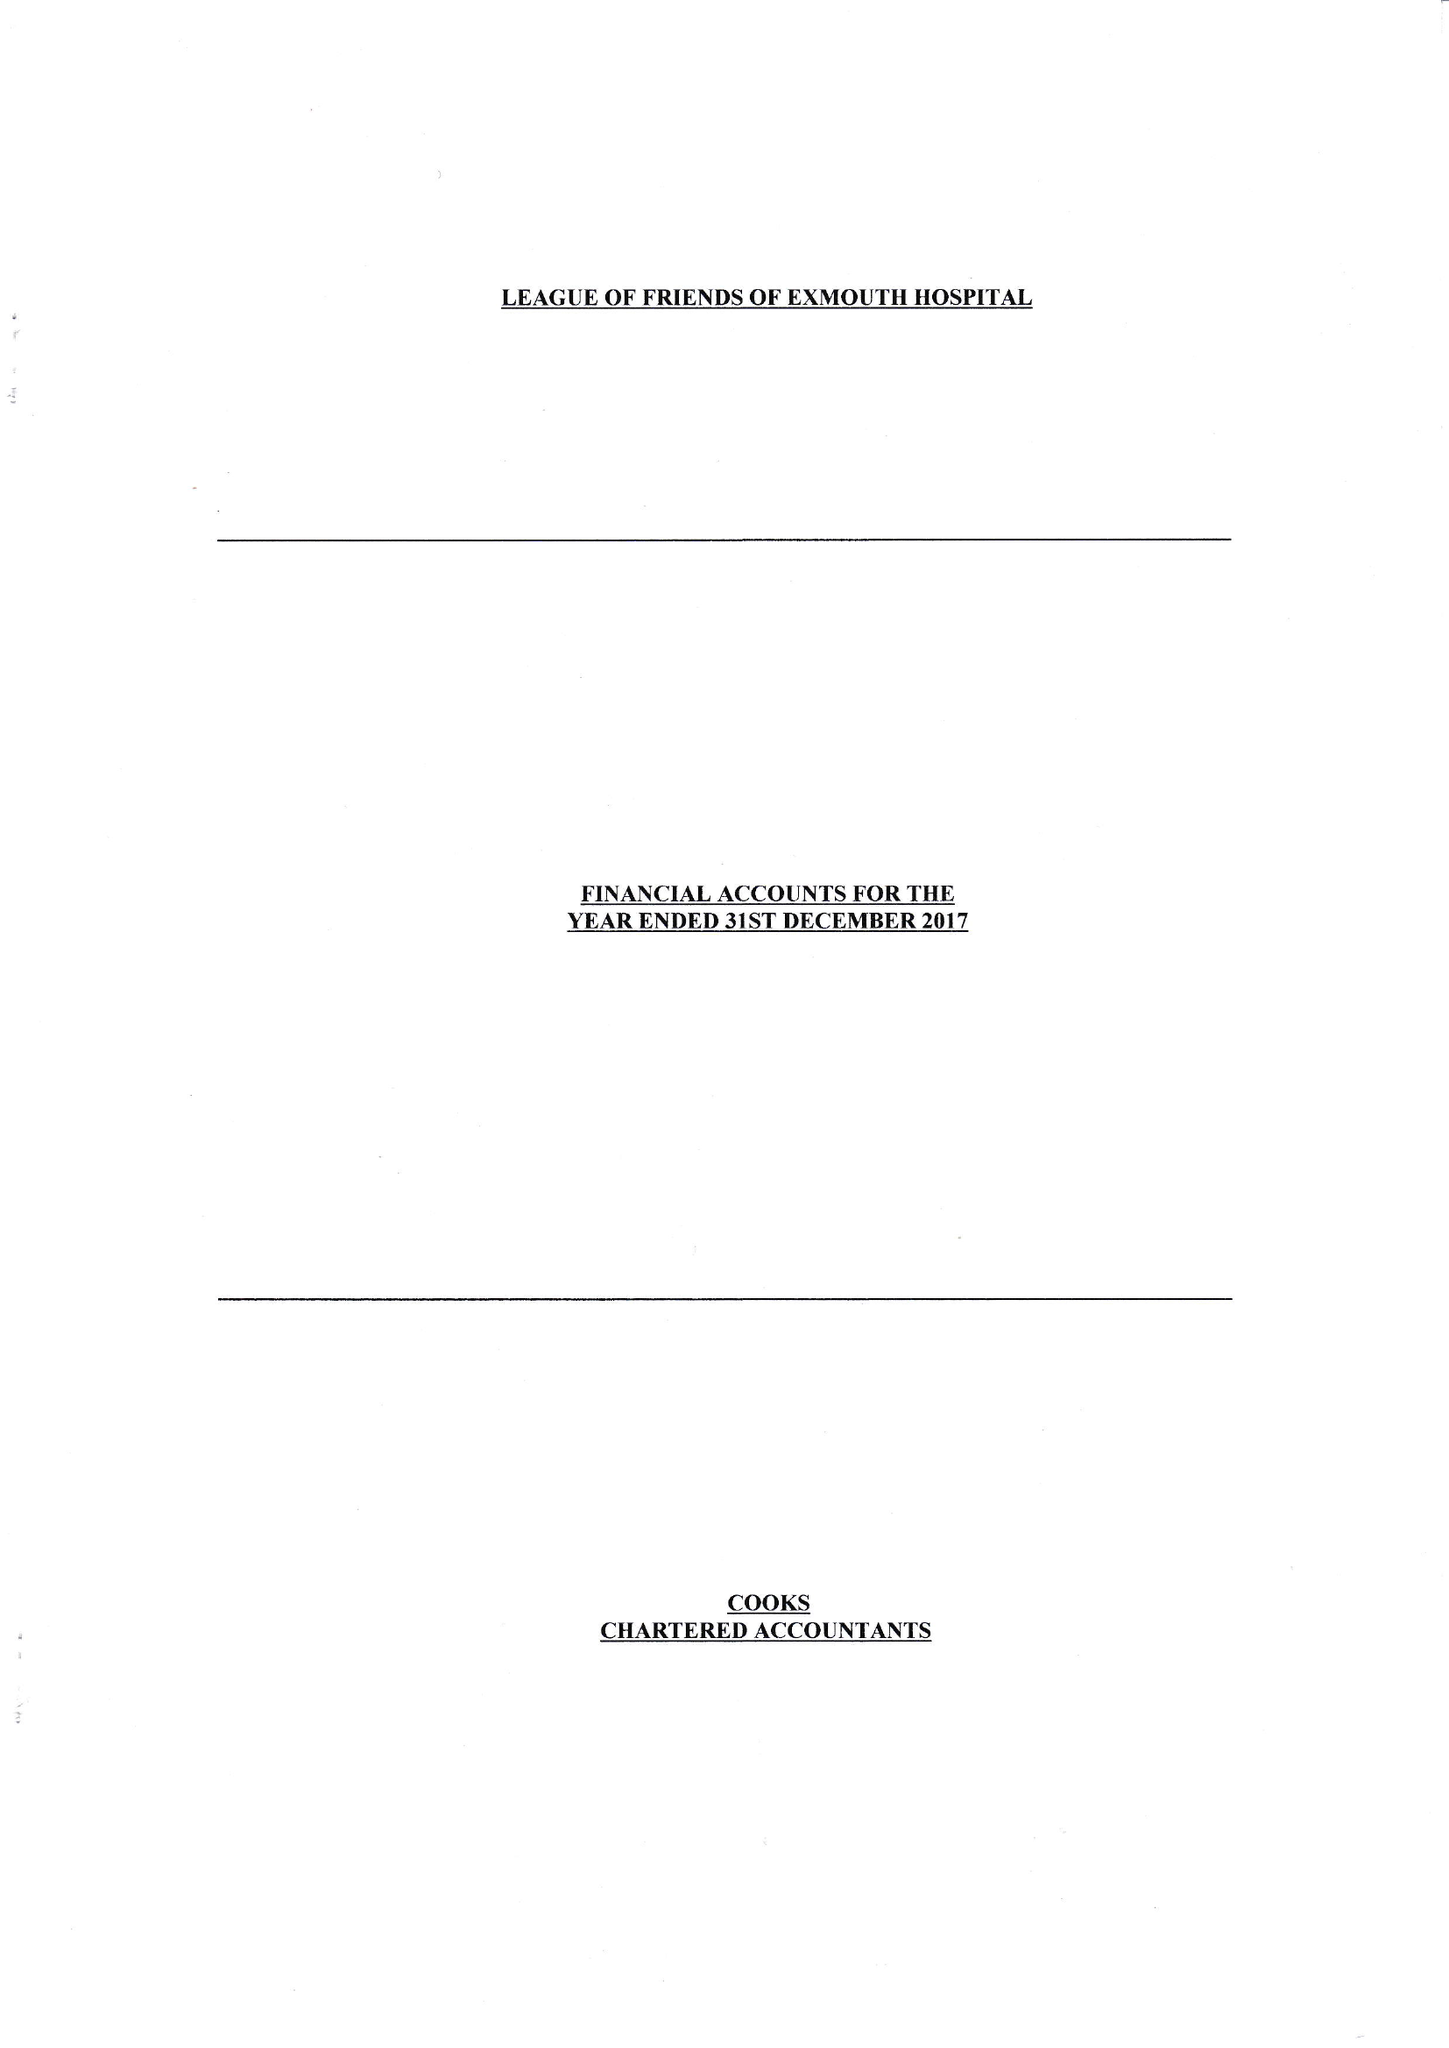What is the value for the report_date?
Answer the question using a single word or phrase. 2017-12-31 